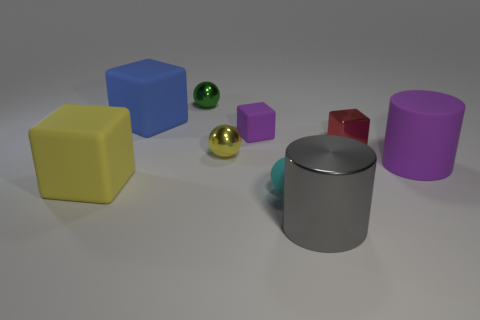What materials do these objects look like they're made of? The objects in the image seem to exhibit different materials: the yellow and red cubes, as well as the blue and purple objects, appear to have a matte finish, suggesting a plastic-like material. The green and gold spherical objects have a shiny, reflective surface, indicative of a metallic material. The cyan cylinder and grey cylinder also have reflective qualities but seem to have a smoother surface, which could imply they are made of polished metal or a similar material. 